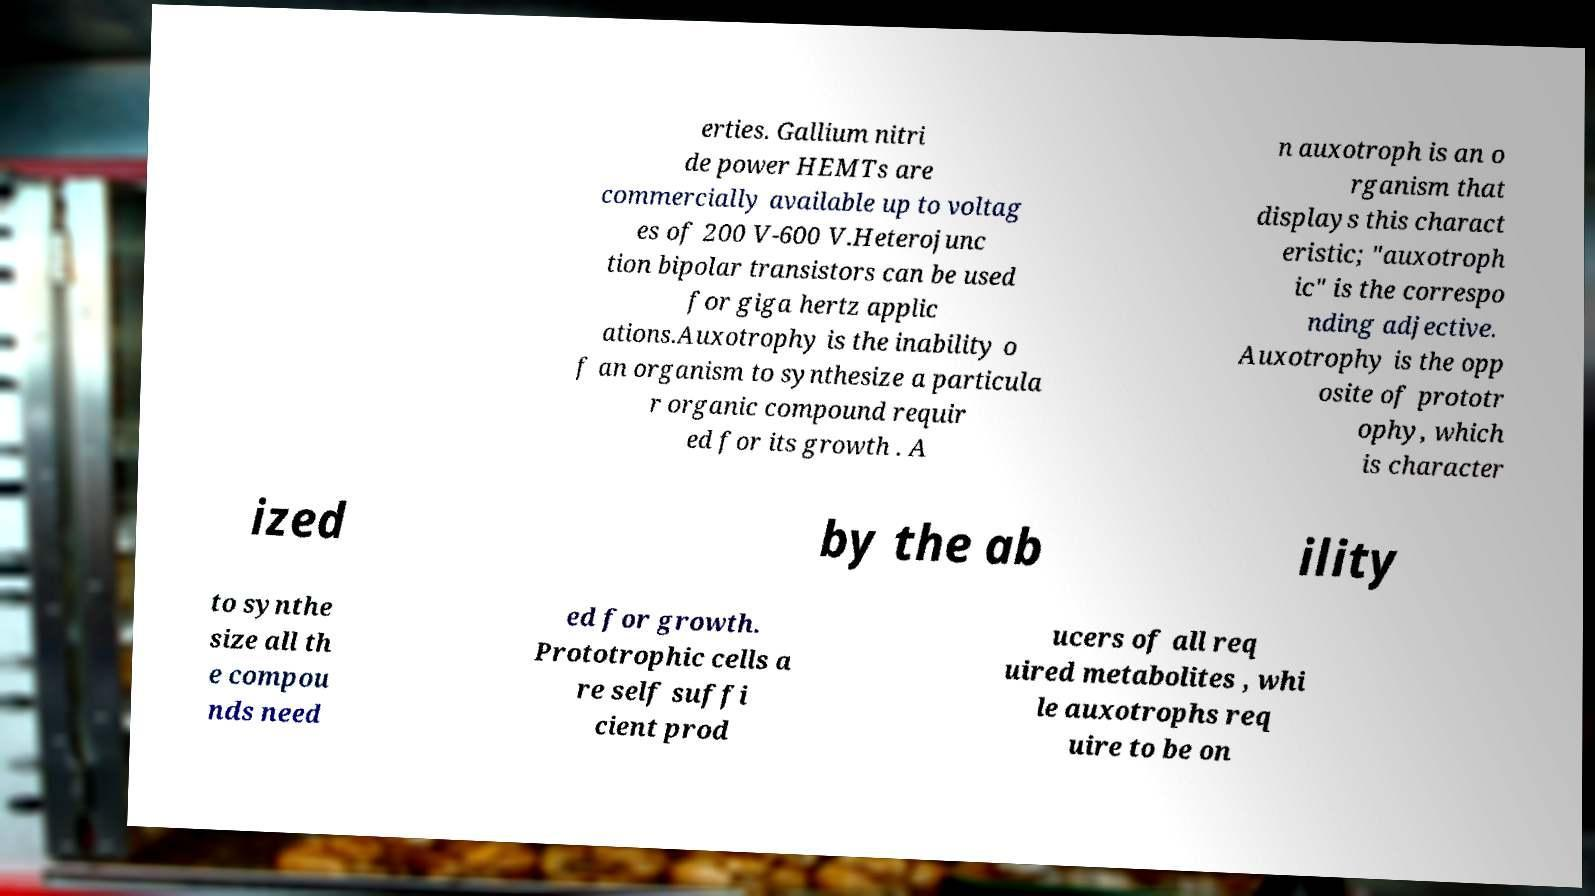Could you assist in decoding the text presented in this image and type it out clearly? erties. Gallium nitri de power HEMTs are commercially available up to voltag es of 200 V-600 V.Heterojunc tion bipolar transistors can be used for giga hertz applic ations.Auxotrophy is the inability o f an organism to synthesize a particula r organic compound requir ed for its growth . A n auxotroph is an o rganism that displays this charact eristic; "auxotroph ic" is the correspo nding adjective. Auxotrophy is the opp osite of prototr ophy, which is character ized by the ab ility to synthe size all th e compou nds need ed for growth. Prototrophic cells a re self suffi cient prod ucers of all req uired metabolites , whi le auxotrophs req uire to be on 